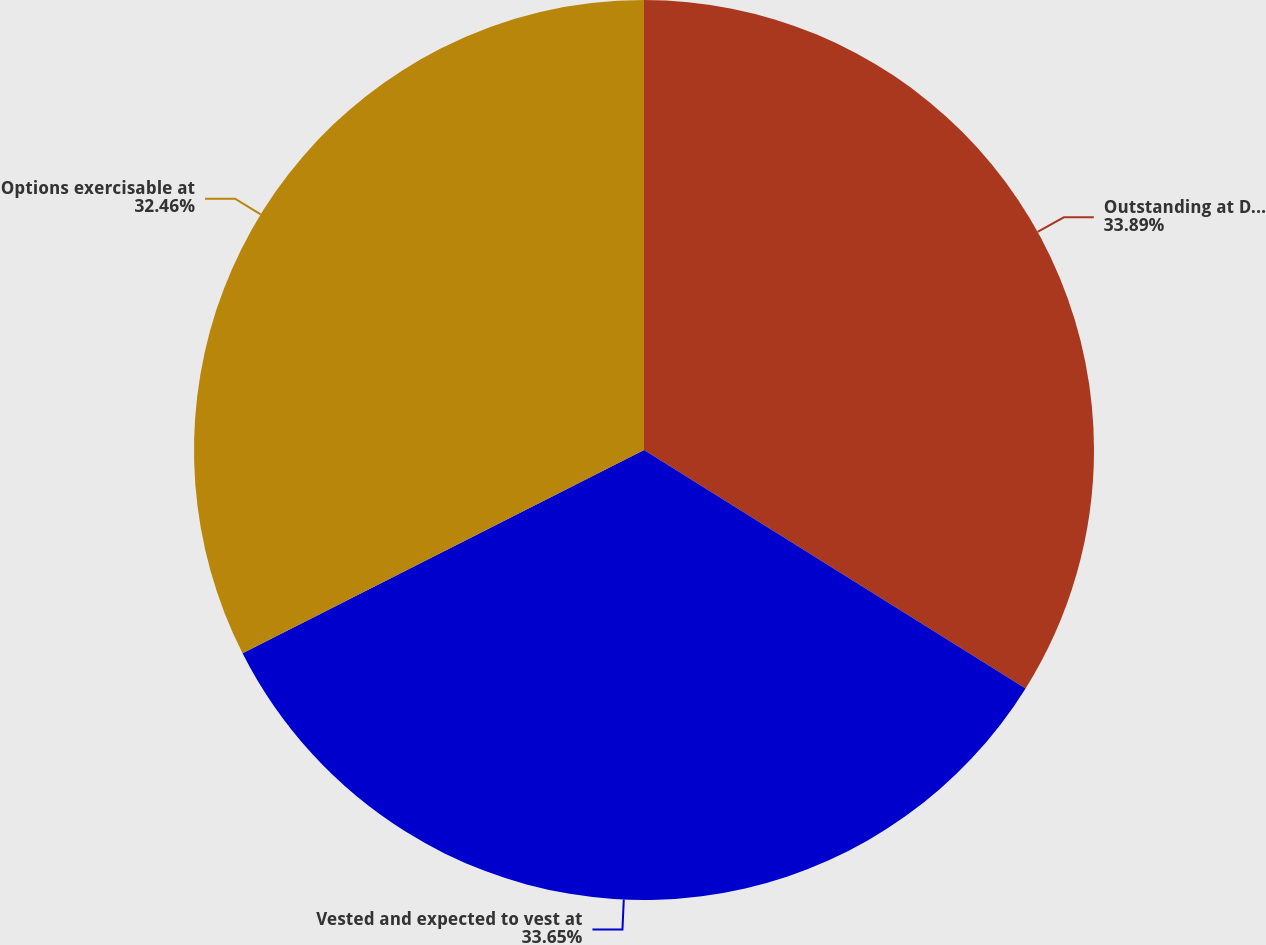<chart> <loc_0><loc_0><loc_500><loc_500><pie_chart><fcel>Outstanding at December 31<fcel>Vested and expected to vest at<fcel>Options exercisable at<nl><fcel>33.89%<fcel>33.65%<fcel>32.46%<nl></chart> 